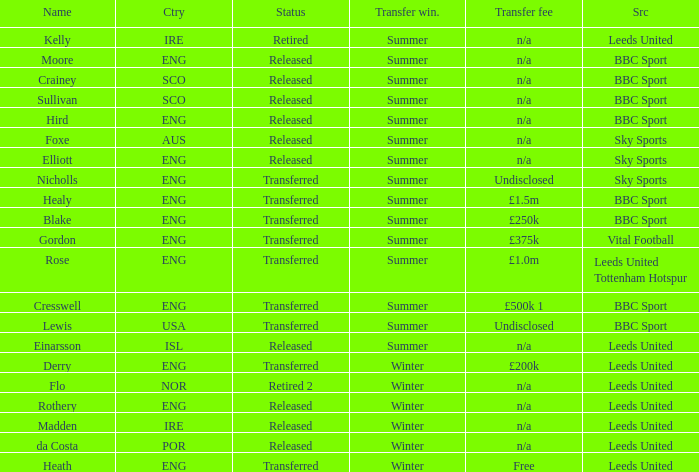What is the current status of the person named Nicholls? Transferred. 